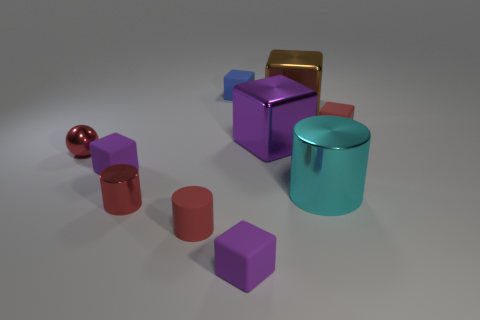Subtract all matte cylinders. How many cylinders are left? 2 Subtract 0 green blocks. How many objects are left? 10 Subtract all cylinders. How many objects are left? 7 Subtract 1 balls. How many balls are left? 0 Subtract all cyan spheres. Subtract all cyan blocks. How many spheres are left? 1 Subtract all gray balls. How many red cylinders are left? 2 Subtract all small rubber objects. Subtract all tiny cyan matte blocks. How many objects are left? 5 Add 8 cyan things. How many cyan things are left? 9 Add 4 purple objects. How many purple objects exist? 7 Subtract all cyan cylinders. How many cylinders are left? 2 